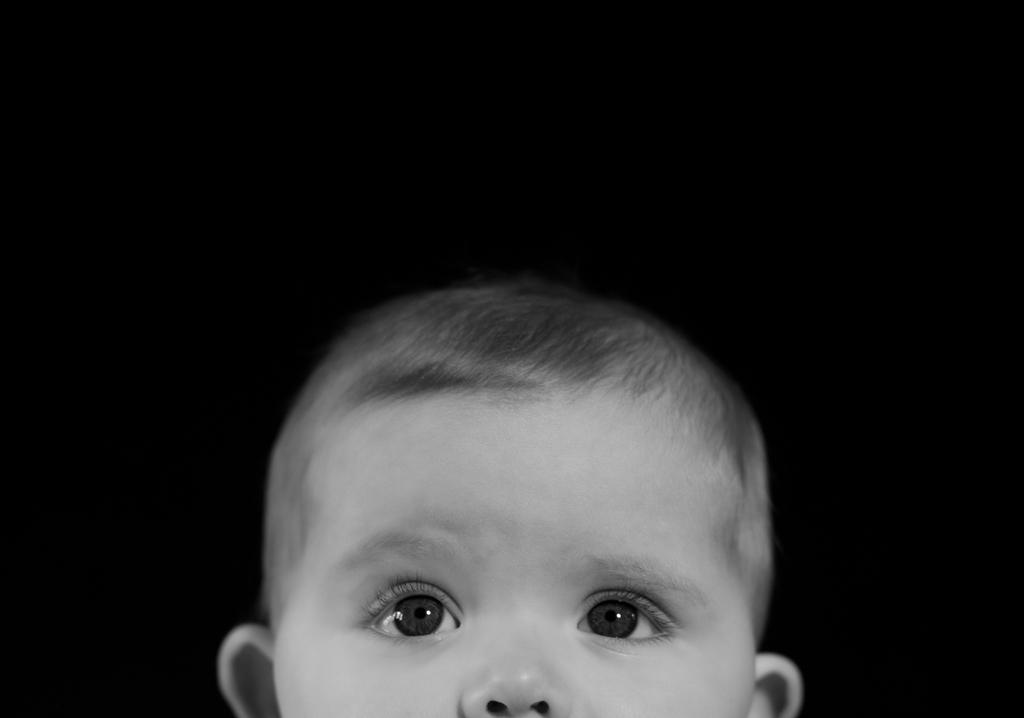What is the main subject of the image? There is a baby's face in the image. What color is the crayon that the baby is holding in the image? There is no crayon present in the image; it only features a baby's face. 